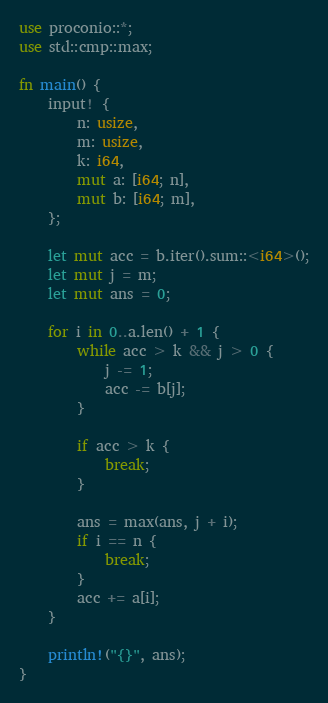Convert code to text. <code><loc_0><loc_0><loc_500><loc_500><_Rust_>use proconio::*;
use std::cmp::max;

fn main() {
    input! {
        n: usize,
        m: usize,
        k: i64,
        mut a: [i64; n],
        mut b: [i64; m],
    };

    let mut acc = b.iter().sum::<i64>();
    let mut j = m;
    let mut ans = 0;

    for i in 0..a.len() + 1 {
        while acc > k && j > 0 {
            j -= 1;
            acc -= b[j];
        }

        if acc > k {
            break;
        }

        ans = max(ans, j + i);
        if i == n {
            break;
        }
        acc += a[i];
    }

    println!("{}", ans);
}
</code> 